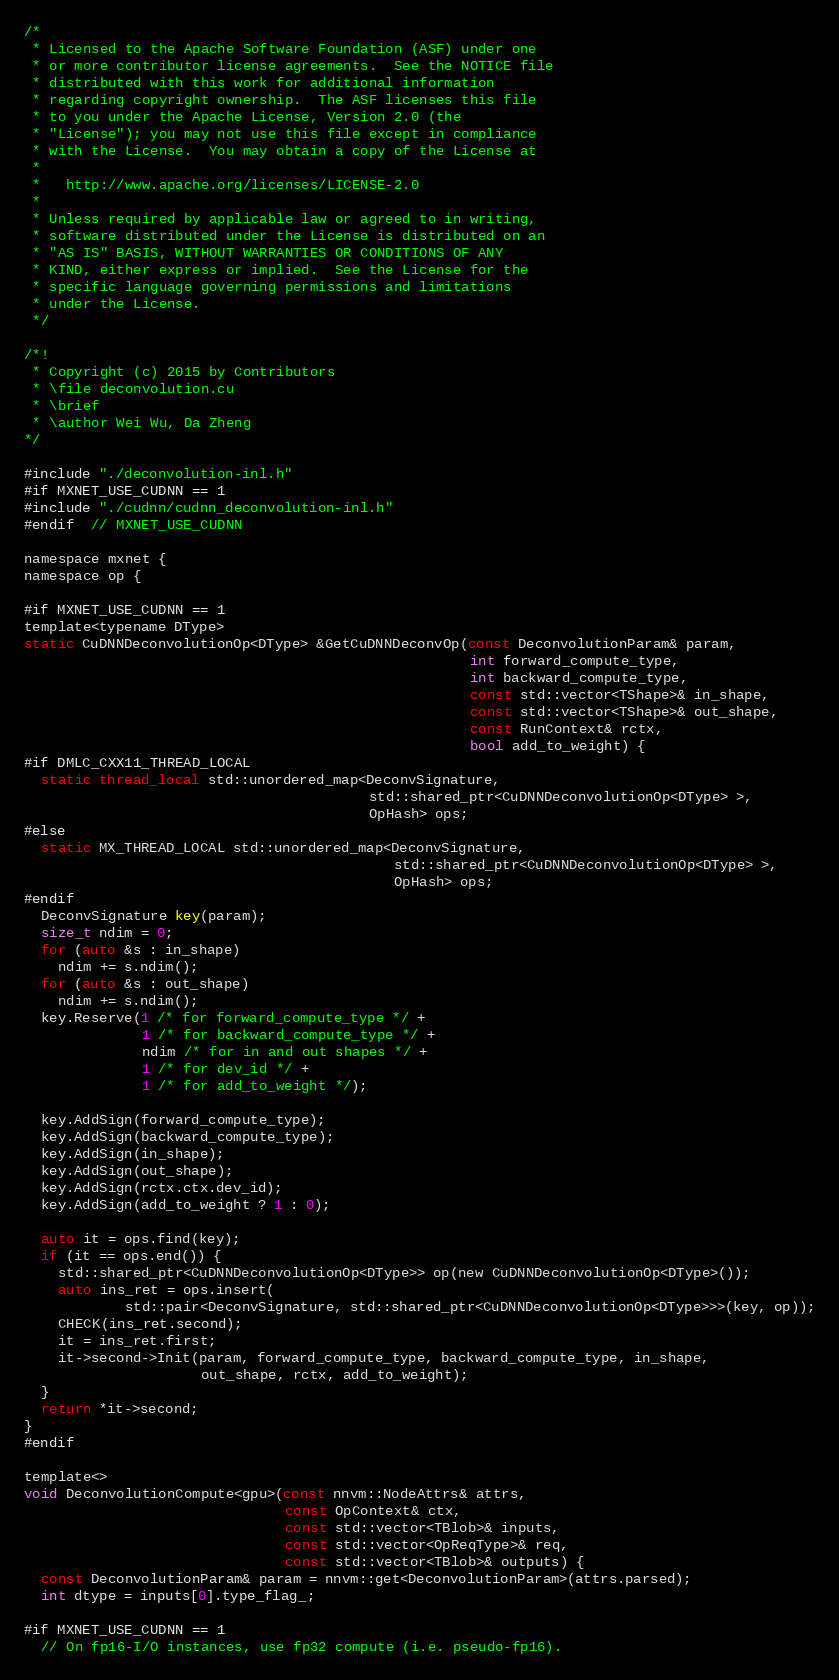Convert code to text. <code><loc_0><loc_0><loc_500><loc_500><_Cuda_>/*
 * Licensed to the Apache Software Foundation (ASF) under one
 * or more contributor license agreements.  See the NOTICE file
 * distributed with this work for additional information
 * regarding copyright ownership.  The ASF licenses this file
 * to you under the Apache License, Version 2.0 (the
 * "License"); you may not use this file except in compliance
 * with the License.  You may obtain a copy of the License at
 *
 *   http://www.apache.org/licenses/LICENSE-2.0
 *
 * Unless required by applicable law or agreed to in writing,
 * software distributed under the License is distributed on an
 * "AS IS" BASIS, WITHOUT WARRANTIES OR CONDITIONS OF ANY
 * KIND, either express or implied.  See the License for the
 * specific language governing permissions and limitations
 * under the License.
 */

/*!
 * Copyright (c) 2015 by Contributors
 * \file deconvolution.cu
 * \brief
 * \author Wei Wu, Da Zheng
*/

#include "./deconvolution-inl.h"
#if MXNET_USE_CUDNN == 1
#include "./cudnn/cudnn_deconvolution-inl.h"
#endif  // MXNET_USE_CUDNN

namespace mxnet {
namespace op {

#if MXNET_USE_CUDNN == 1
template<typename DType>
static CuDNNDeconvolutionOp<DType> &GetCuDNNDeconvOp(const DeconvolutionParam& param,
                                                     int forward_compute_type,
                                                     int backward_compute_type,
                                                     const std::vector<TShape>& in_shape,
                                                     const std::vector<TShape>& out_shape,
                                                     const RunContext& rctx,
                                                     bool add_to_weight) {
#if DMLC_CXX11_THREAD_LOCAL
  static thread_local std::unordered_map<DeconvSignature,
                                         std::shared_ptr<CuDNNDeconvolutionOp<DType> >,
                                         OpHash> ops;
#else
  static MX_THREAD_LOCAL std::unordered_map<DeconvSignature,
                                            std::shared_ptr<CuDNNDeconvolutionOp<DType> >,
                                            OpHash> ops;
#endif
  DeconvSignature key(param);
  size_t ndim = 0;
  for (auto &s : in_shape)
    ndim += s.ndim();
  for (auto &s : out_shape)
    ndim += s.ndim();
  key.Reserve(1 /* for forward_compute_type */ +
              1 /* for backward_compute_type */ +
              ndim /* for in and out shapes */ +
              1 /* for dev_id */ +
              1 /* for add_to_weight */);

  key.AddSign(forward_compute_type);
  key.AddSign(backward_compute_type);
  key.AddSign(in_shape);
  key.AddSign(out_shape);
  key.AddSign(rctx.ctx.dev_id);
  key.AddSign(add_to_weight ? 1 : 0);

  auto it = ops.find(key);
  if (it == ops.end()) {
    std::shared_ptr<CuDNNDeconvolutionOp<DType>> op(new CuDNNDeconvolutionOp<DType>());
    auto ins_ret = ops.insert(
            std::pair<DeconvSignature, std::shared_ptr<CuDNNDeconvolutionOp<DType>>>(key, op));
    CHECK(ins_ret.second);
    it = ins_ret.first;
    it->second->Init(param, forward_compute_type, backward_compute_type, in_shape,
                     out_shape, rctx, add_to_weight);
  }
  return *it->second;
}
#endif

template<>
void DeconvolutionCompute<gpu>(const nnvm::NodeAttrs& attrs,
                               const OpContext& ctx,
                               const std::vector<TBlob>& inputs,
                               const std::vector<OpReqType>& req,
                               const std::vector<TBlob>& outputs) {
  const DeconvolutionParam& param = nnvm::get<DeconvolutionParam>(attrs.parsed);
  int dtype = inputs[0].type_flag_;

#if MXNET_USE_CUDNN == 1
  // On fp16-I/O instances, use fp32 compute (i.e. pseudo-fp16).</code> 